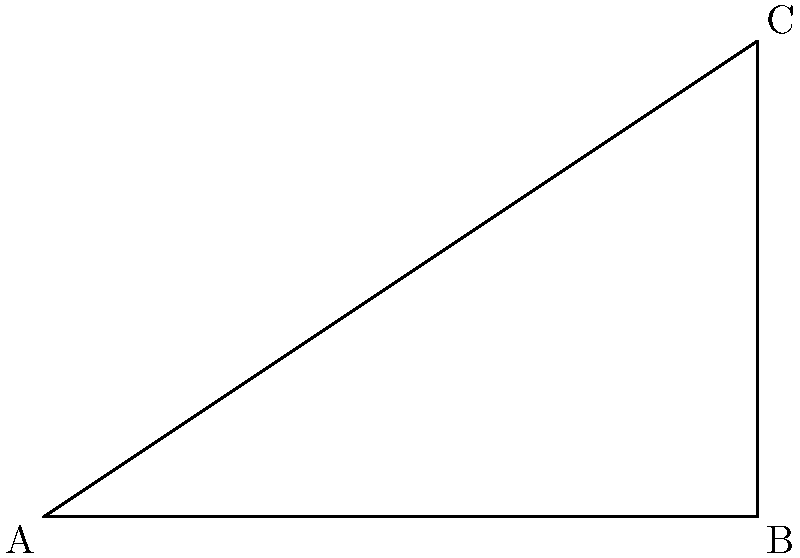In the diagram above, a right triangle represents the optimal angle for a golf swing. If the base of the triangle (AB) is 6 cm and the height (BC) is 4 cm, what is the optimal angle $\theta$ for the golf swing? To find the optimal angle $\theta$ for the golf swing, we need to use trigonometry. Here's how we can solve this step-by-step:

1. We have a right triangle with the following measurements:
   - Base (AB) = 6 cm
   - Height (BC) = 4 cm

2. The angle $\theta$ is formed between the hypotenuse (AC) and the base (AB).

3. To find this angle, we can use the arctangent (tan^(-1)) function, as tangent is the ratio of the opposite side to the adjacent side.

4. In this case:
   $\tan(\theta) = \frac{\text{opposite}}{\text{adjacent}} = \frac{BC}{AB} = \frac{4}{6}$

5. To find $\theta$, we take the arctangent of this ratio:
   $\theta = \tan^{-1}(\frac{4}{6})$

6. Simplifying the fraction:
   $\theta = \tan^{-1}(\frac{2}{3})$

7. Using a calculator or trigonometric tables:
   $\theta \approx 33.69^\circ$

Therefore, the optimal angle for the golf swing in this scenario is approximately 33.69°.
Answer: $33.69^\circ$ 